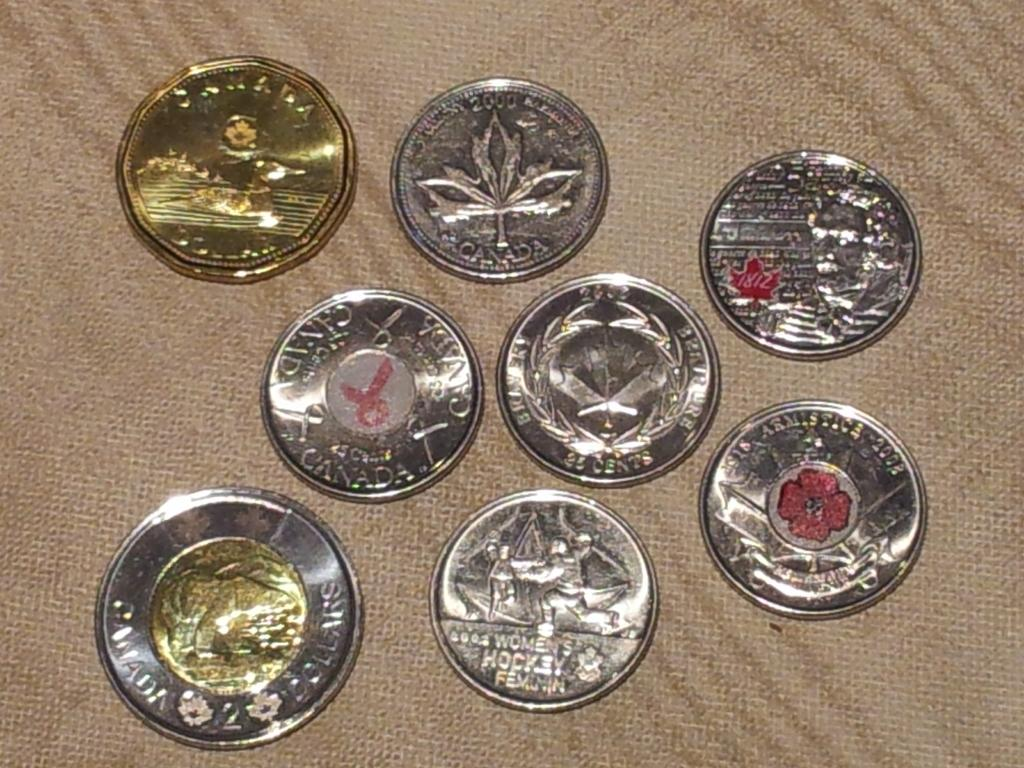<image>
Share a concise interpretation of the image provided. the word hockey is on the coin on the ground 